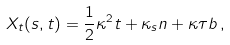<formula> <loc_0><loc_0><loc_500><loc_500>X _ { t } ( s , t ) = \frac { 1 } { 2 } \kappa ^ { 2 } t + \kappa _ { s } n + \kappa \tau b \, ,</formula> 